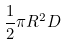<formula> <loc_0><loc_0><loc_500><loc_500>\frac { 1 } { 2 } \pi R ^ { 2 } D</formula> 